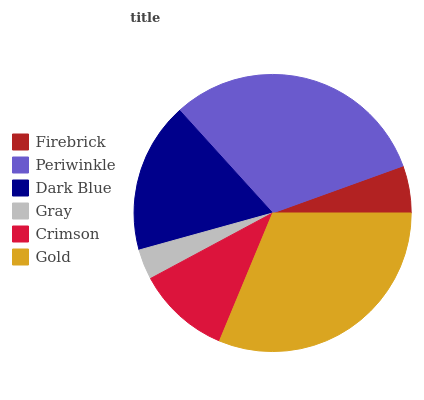Is Gray the minimum?
Answer yes or no. Yes. Is Gold the maximum?
Answer yes or no. Yes. Is Periwinkle the minimum?
Answer yes or no. No. Is Periwinkle the maximum?
Answer yes or no. No. Is Periwinkle greater than Firebrick?
Answer yes or no. Yes. Is Firebrick less than Periwinkle?
Answer yes or no. Yes. Is Firebrick greater than Periwinkle?
Answer yes or no. No. Is Periwinkle less than Firebrick?
Answer yes or no. No. Is Dark Blue the high median?
Answer yes or no. Yes. Is Crimson the low median?
Answer yes or no. Yes. Is Crimson the high median?
Answer yes or no. No. Is Periwinkle the low median?
Answer yes or no. No. 